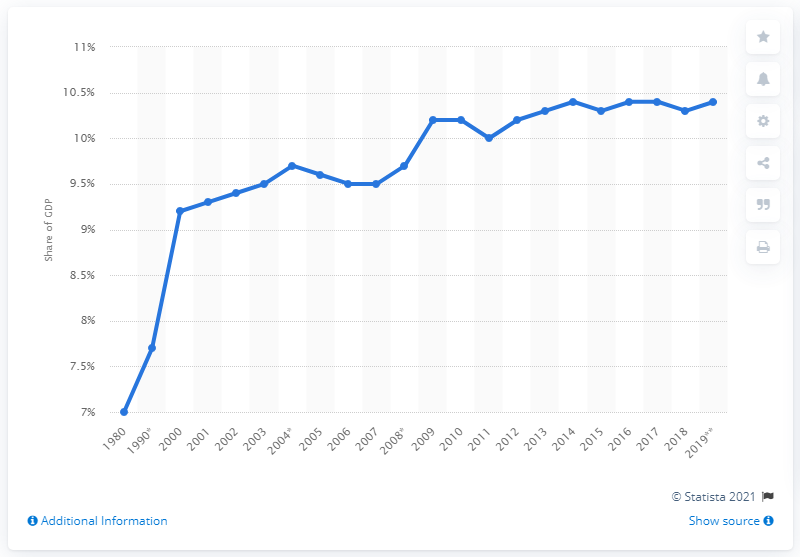Identify some key points in this picture. Since the year 1980, Austria's total expenditure on health has generally increased. 